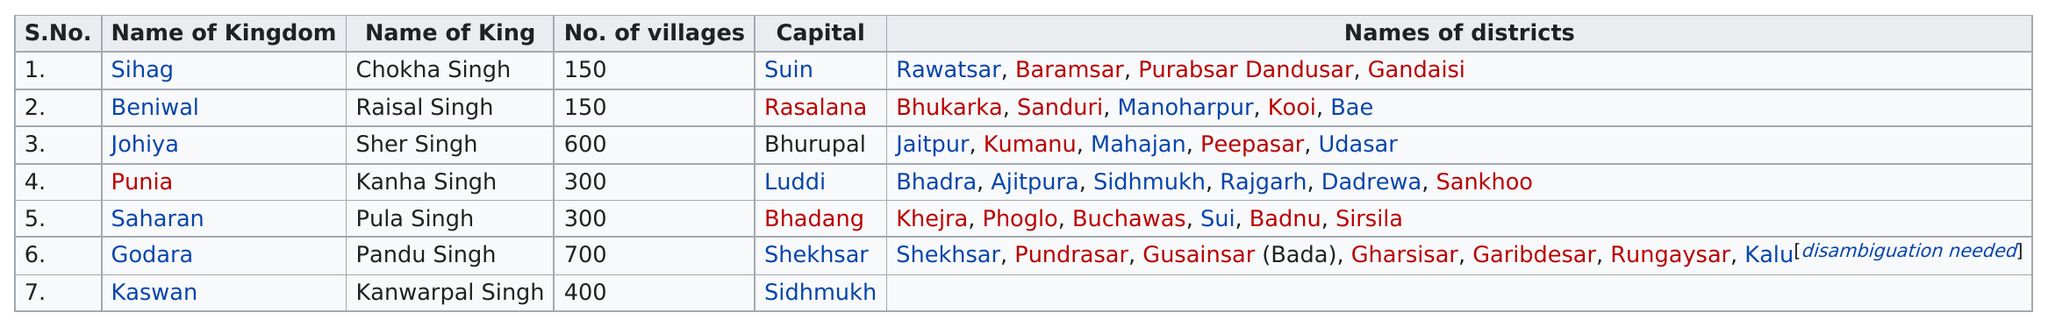Draw attention to some important aspects in this diagram. Beniwal is the next kingdom listed after Sihag in the alphabetical order. The kingdom of Johiya was the second-most populous kingdom, second only to Godara, which was known to have the most villages in the kingdom. According to the chart, Johiya has 600 villages. The total number of districts within the state of Godara was 7. Chokha Singh was the king of the Sihag kingdom. 